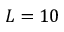Convert formula to latex. <formula><loc_0><loc_0><loc_500><loc_500>L = 1 0</formula> 